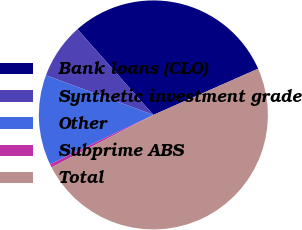Convert chart to OTSL. <chart><loc_0><loc_0><loc_500><loc_500><pie_chart><fcel>Bank loans (CLO)<fcel>Synthetic investment grade<fcel>Other<fcel>Subprime ABS<fcel>Total<nl><fcel>29.92%<fcel>7.85%<fcel>12.7%<fcel>0.49%<fcel>49.04%<nl></chart> 